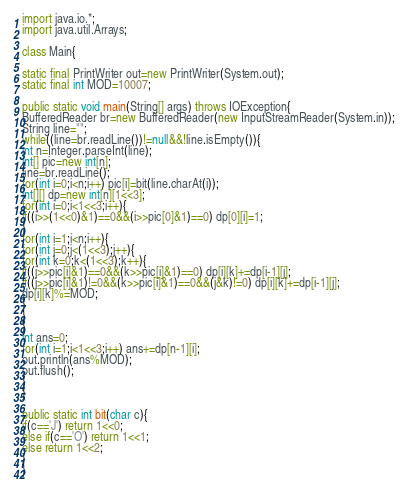Convert code to text. <code><loc_0><loc_0><loc_500><loc_500><_Java_>import java.io.*;
import java.util.Arrays;
   
class Main{
  
static final PrintWriter out=new PrintWriter(System.out);
static final int MOD=10007;
   
public static void main(String[] args) throws IOException{
BufferedReader br=new BufferedReader(new InputStreamReader(System.in));
String line="";
while((line=br.readLine())!=null&&!line.isEmpty()){
int n=Integer.parseInt(line);
int[] pic=new int[n];
line=br.readLine();
for(int i=0;i<n;i++) pic[i]=bit(line.charAt(i));
int[][] dp=new int[n][1<<3];
for(int i=0;i<1<<3;i++){
if((i>>(1<<0)&1)==0&&(i>>pic[0]&1)==0) dp[0][i]=1;
}
for(int i=1;i<n;i++){
for(int j=0;j<(1<<3);j++){
for(int k=0;k<(1<<3);k++){
if((j>>pic[i]&1)==0&&(k>>pic[i]&1)==0) dp[i][k]+=dp[i-1][j];
if((j>>pic[i]&1)!=0&&(k>>pic[i]&1)==0&&(j&k)!=0) dp[i][k]+=dp[i-1][j];
dp[i][k]%=MOD;
}
}
}
int ans=0;
for(int i=1;i<1<<3;i++) ans+=dp[n-1][i];
out.println(ans%MOD);
out.flush();
}
}
 
public static int bit(char c){
if(c=='J') return 1<<0;
else if(c=='O') return 1<<1;
else return 1<<2;
}
}</code> 